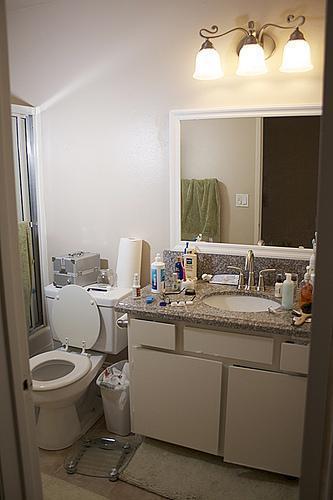How many people are wearing white standing around the pool?
Give a very brief answer. 0. 